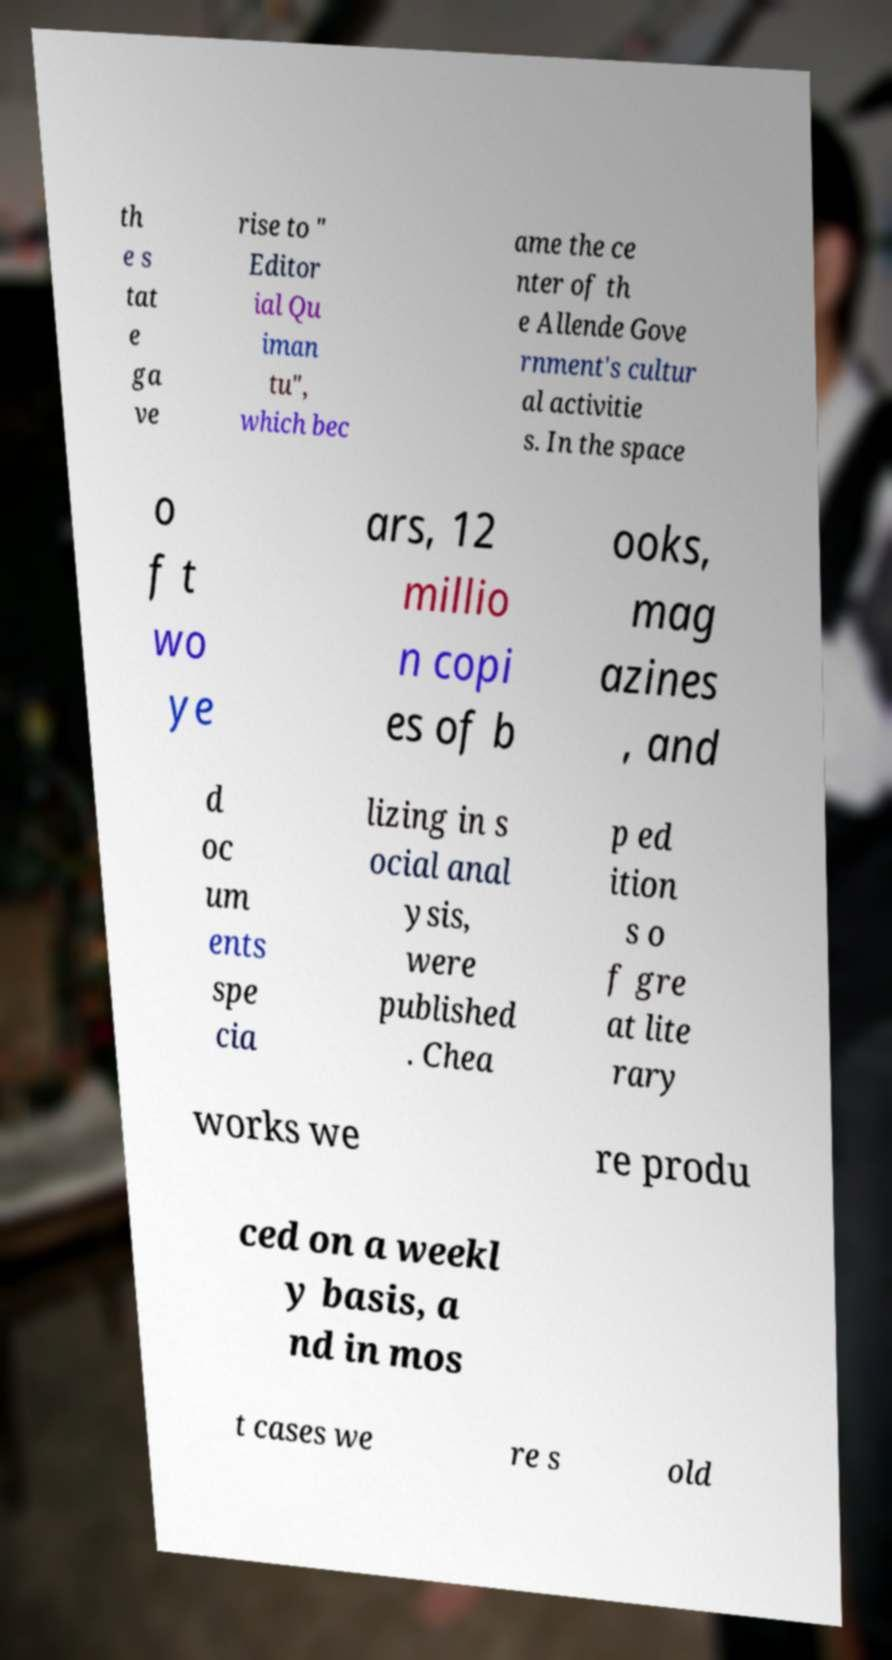What messages or text are displayed in this image? I need them in a readable, typed format. th e s tat e ga ve rise to " Editor ial Qu iman tu", which bec ame the ce nter of th e Allende Gove rnment's cultur al activitie s. In the space o f t wo ye ars, 12 millio n copi es of b ooks, mag azines , and d oc um ents spe cia lizing in s ocial anal ysis, were published . Chea p ed ition s o f gre at lite rary works we re produ ced on a weekl y basis, a nd in mos t cases we re s old 